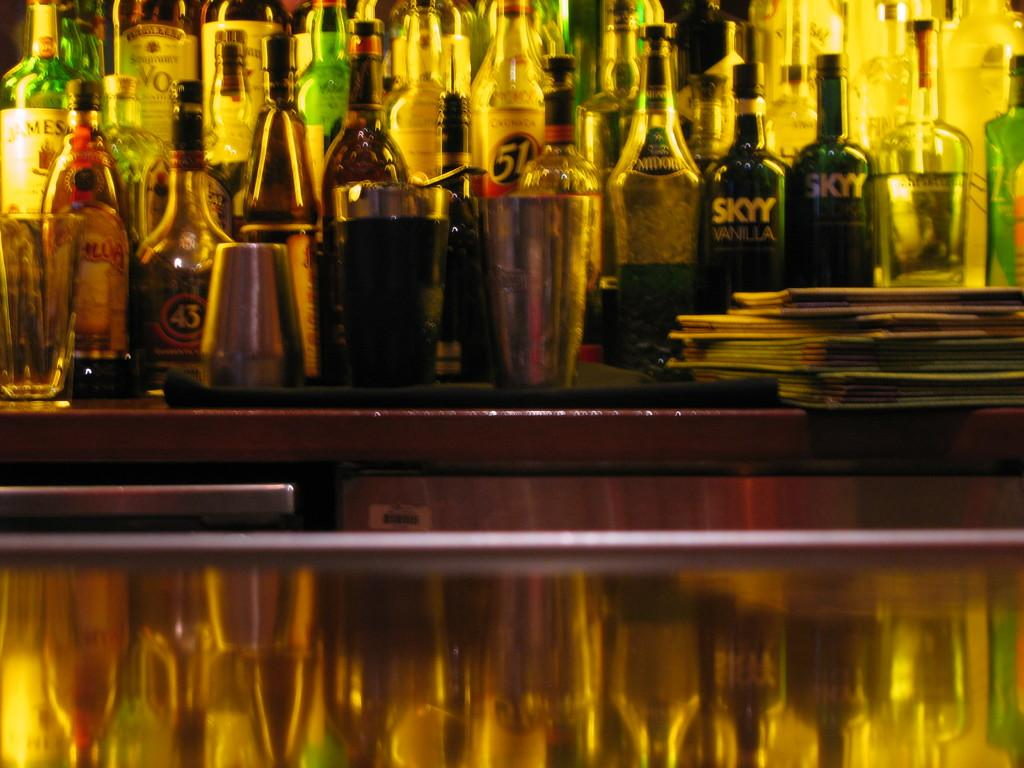<image>
Provide a brief description of the given image. Rows and rows of alcohol bottles including SKY vodka. 